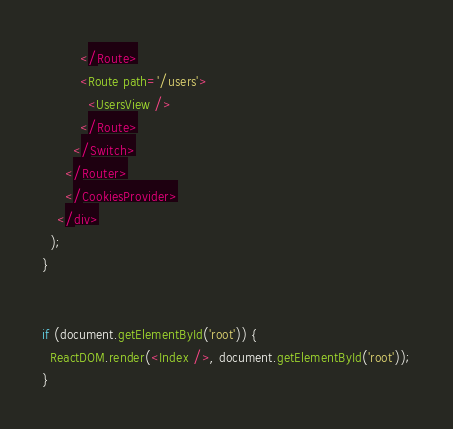Convert code to text. <code><loc_0><loc_0><loc_500><loc_500><_JavaScript_>          </Route>
          <Route path='/users'>
            <UsersView />
          </Route>
        </Switch>
      </Router>
      </CookiesProvider>
    </div>
  );
}


if (document.getElementById('root')) {
  ReactDOM.render(<Index />, document.getElementById('root'));
}
</code> 